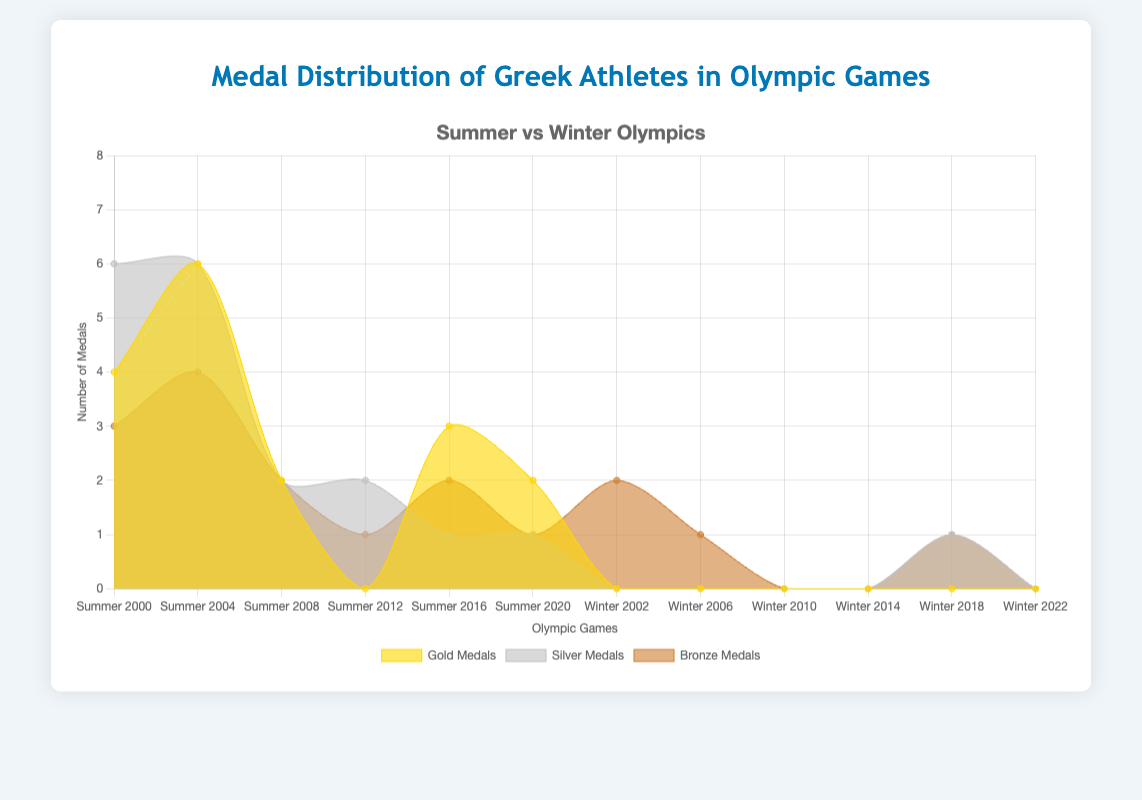What's the total number of gold medals won by Greek athletes in Summer Olympics? Sum the gold medals from the summer games: 4 + 6 + 2 + 0 + 3 + 2
Answer: 17 Which Olympics saw the highest number of bronze medals won by Greek athletes? Look for the peak in the bronze medals data: Summer 2004 with 4 bronze medals
Answer: Summer 2004 How did the number of silver medals in Winter Olympics 2018 compare to the other Winter Olympics? Winter 2018 has 1 silver medal, while other Winter Olympics have 0 silver medals except 2006 which also has 0
Answer: Winter 2018 had more than all others except 2006 which was the same Which type of medal was least frequently won by Greek athletes in Summer 2012? Check the values for Summer 2012, Gold: 0, Silver: 2, Bronze: 1
Answer: Gold How many total medals did Greek athletes win in Summer 2004? Add up all medals for Summer 2004: Gold 6 + Silver 6 + Bronze 4
Answer: 16 Compare the number of gold medals won in Summer 2000 and Summer 2004. Which year had more? Compare 4 gold medals in Summer 2000 to 6 in Summer 2004
Answer: Summer 2004 What is the trend of gold medal wins for Greek athletes in Summer Olympics from 2000 to 2020? Observe the number of gold medals over the years: 4, 6, 2, 0, 3, 2
Answer: Generally decreasing with some fluctuations Identify years where Greek athletes won no gold medals in Summer Olympics. Check for zero values in the gold medal data for Summer: Summer 2012
Answer: Summer 2012 Are there any Winter Olympics where Greek athletes won medals of each type (gold, silver, bronze)? Check each Winter Olympics data for having all three types of medals, no Winter Olympics meets this criterion
Answer: No During which Winter Olympics did Greek athletes win the highest total number of medals? Calculate the total medals for each Winter Olympic, Winter 2002 had 2 bronze medals, Winter 2006 1 bronze, Winter 2018 1 silver, 1 bronze
Answer: Winter 2002 